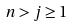<formula> <loc_0><loc_0><loc_500><loc_500>n > j \geq 1</formula> 